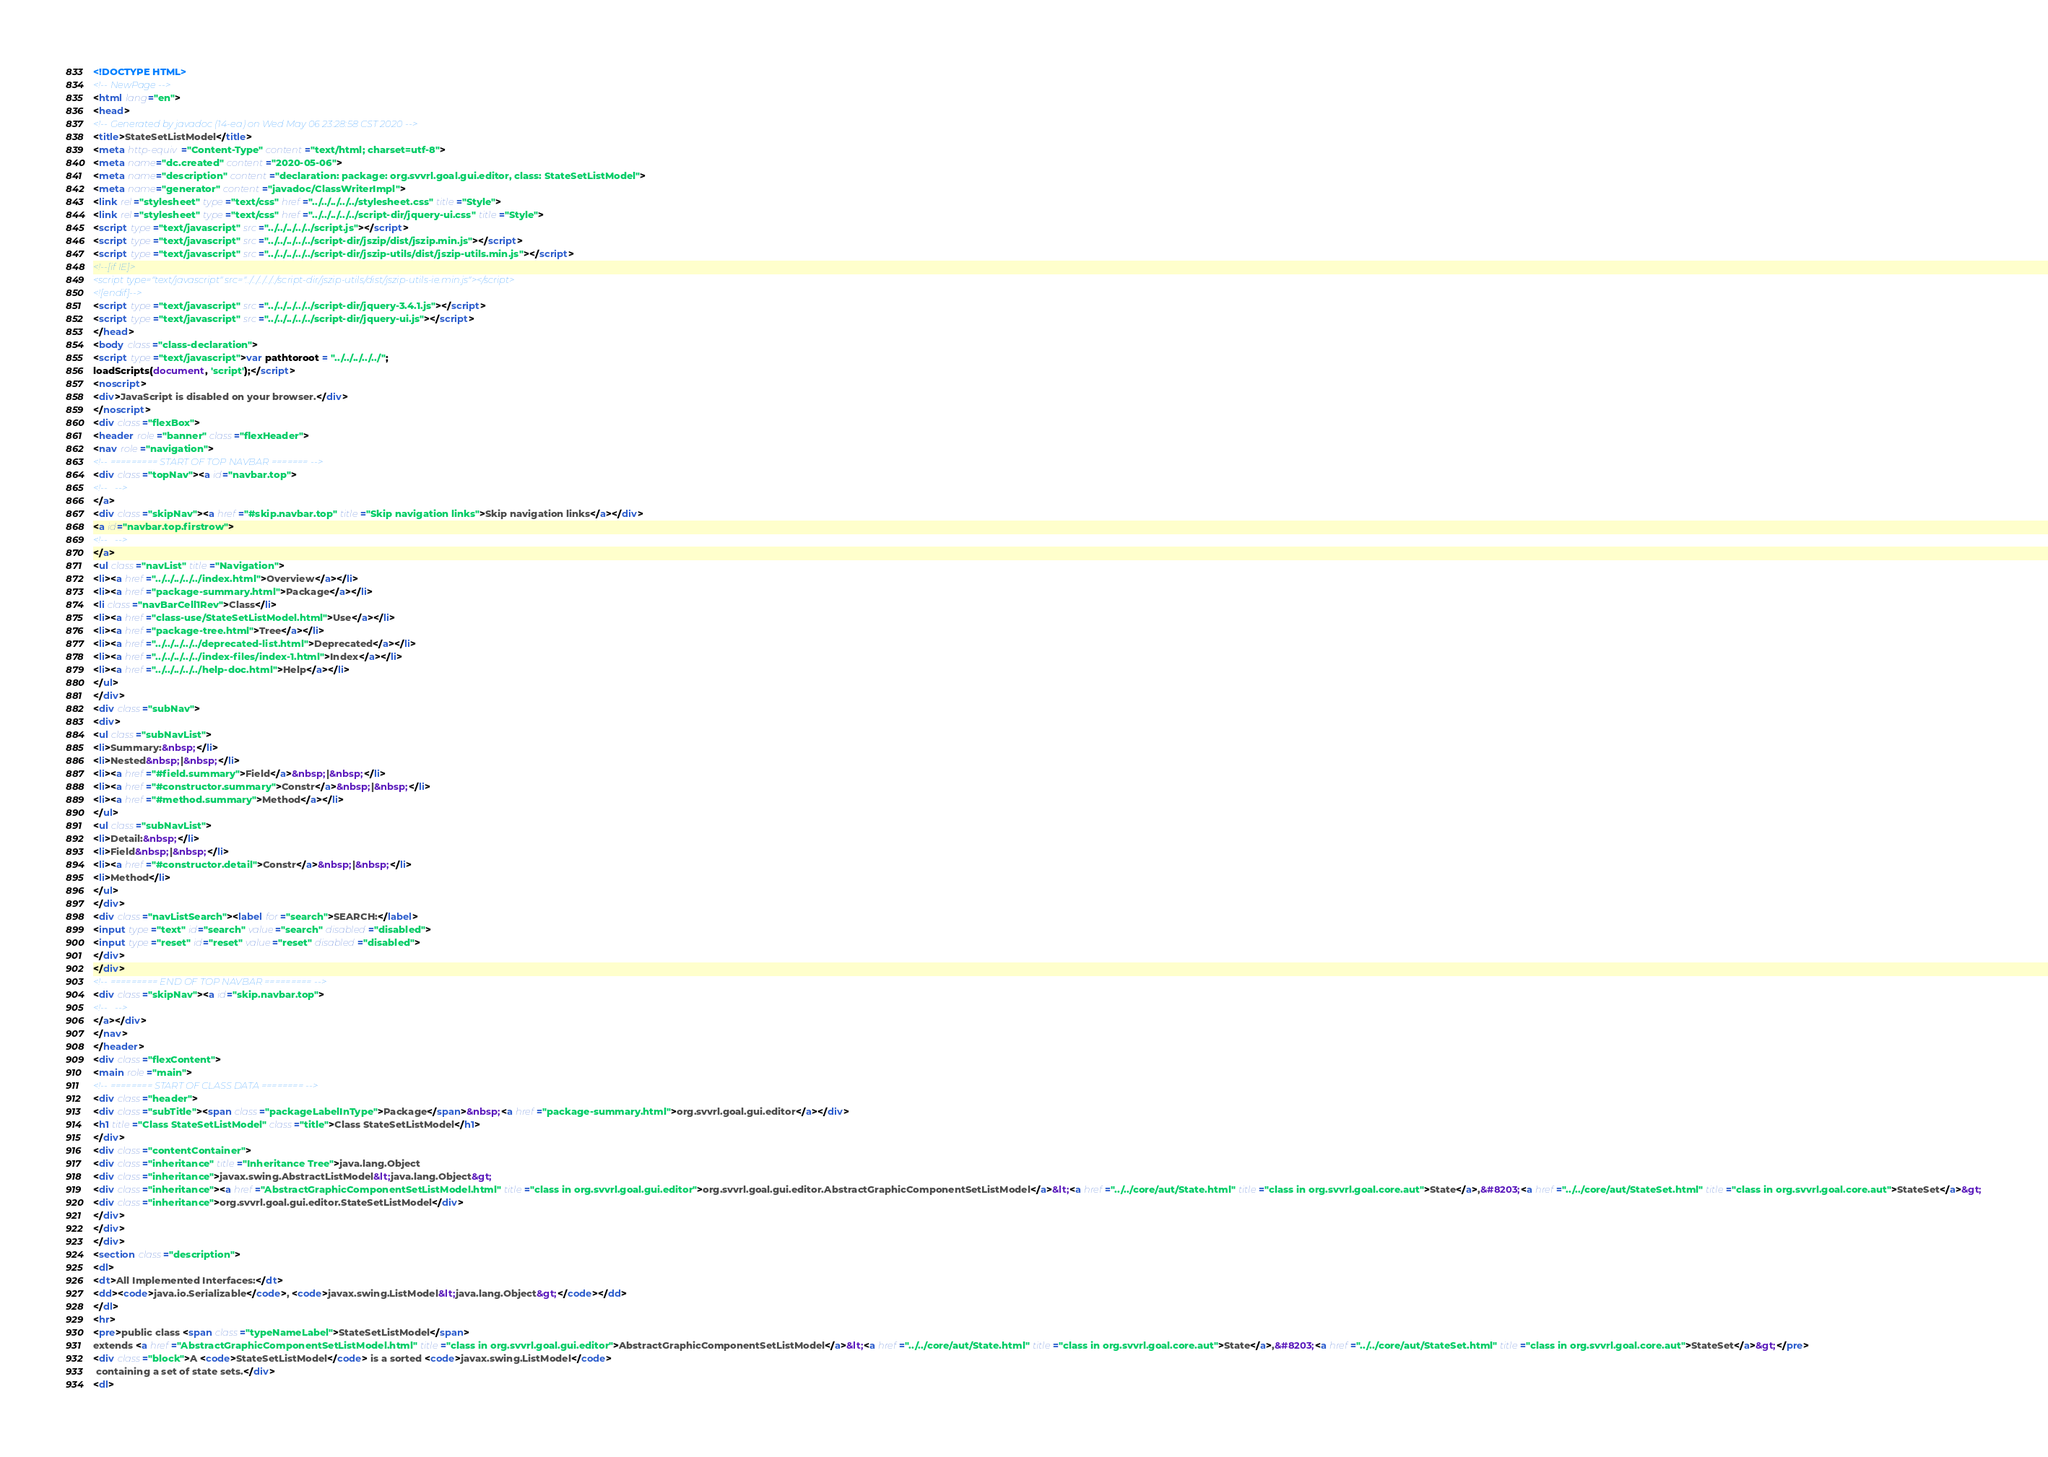Convert code to text. <code><loc_0><loc_0><loc_500><loc_500><_HTML_><!DOCTYPE HTML>
<!-- NewPage -->
<html lang="en">
<head>
<!-- Generated by javadoc (14-ea) on Wed May 06 23:28:58 CST 2020 -->
<title>StateSetListModel</title>
<meta http-equiv="Content-Type" content="text/html; charset=utf-8">
<meta name="dc.created" content="2020-05-06">
<meta name="description" content="declaration: package: org.svvrl.goal.gui.editor, class: StateSetListModel">
<meta name="generator" content="javadoc/ClassWriterImpl">
<link rel="stylesheet" type="text/css" href="../../../../../stylesheet.css" title="Style">
<link rel="stylesheet" type="text/css" href="../../../../../script-dir/jquery-ui.css" title="Style">
<script type="text/javascript" src="../../../../../script.js"></script>
<script type="text/javascript" src="../../../../../script-dir/jszip/dist/jszip.min.js"></script>
<script type="text/javascript" src="../../../../../script-dir/jszip-utils/dist/jszip-utils.min.js"></script>
<!--[if IE]>
<script type="text/javascript" src="../../../../../script-dir/jszip-utils/dist/jszip-utils-ie.min.js"></script>
<![endif]-->
<script type="text/javascript" src="../../../../../script-dir/jquery-3.4.1.js"></script>
<script type="text/javascript" src="../../../../../script-dir/jquery-ui.js"></script>
</head>
<body class="class-declaration">
<script type="text/javascript">var pathtoroot = "../../../../../";
loadScripts(document, 'script');</script>
<noscript>
<div>JavaScript is disabled on your browser.</div>
</noscript>
<div class="flexBox">
<header role="banner" class="flexHeader">
<nav role="navigation">
<!-- ========= START OF TOP NAVBAR ======= -->
<div class="topNav"><a id="navbar.top">
<!--   -->
</a>
<div class="skipNav"><a href="#skip.navbar.top" title="Skip navigation links">Skip navigation links</a></div>
<a id="navbar.top.firstrow">
<!--   -->
</a>
<ul class="navList" title="Navigation">
<li><a href="../../../../../index.html">Overview</a></li>
<li><a href="package-summary.html">Package</a></li>
<li class="navBarCell1Rev">Class</li>
<li><a href="class-use/StateSetListModel.html">Use</a></li>
<li><a href="package-tree.html">Tree</a></li>
<li><a href="../../../../../deprecated-list.html">Deprecated</a></li>
<li><a href="../../../../../index-files/index-1.html">Index</a></li>
<li><a href="../../../../../help-doc.html">Help</a></li>
</ul>
</div>
<div class="subNav">
<div>
<ul class="subNavList">
<li>Summary:&nbsp;</li>
<li>Nested&nbsp;|&nbsp;</li>
<li><a href="#field.summary">Field</a>&nbsp;|&nbsp;</li>
<li><a href="#constructor.summary">Constr</a>&nbsp;|&nbsp;</li>
<li><a href="#method.summary">Method</a></li>
</ul>
<ul class="subNavList">
<li>Detail:&nbsp;</li>
<li>Field&nbsp;|&nbsp;</li>
<li><a href="#constructor.detail">Constr</a>&nbsp;|&nbsp;</li>
<li>Method</li>
</ul>
</div>
<div class="navListSearch"><label for="search">SEARCH:</label>
<input type="text" id="search" value="search" disabled="disabled">
<input type="reset" id="reset" value="reset" disabled="disabled">
</div>
</div>
<!-- ========= END OF TOP NAVBAR ========= -->
<div class="skipNav"><a id="skip.navbar.top">
<!--   -->
</a></div>
</nav>
</header>
<div class="flexContent">
<main role="main">
<!-- ======== START OF CLASS DATA ======== -->
<div class="header">
<div class="subTitle"><span class="packageLabelInType">Package</span>&nbsp;<a href="package-summary.html">org.svvrl.goal.gui.editor</a></div>
<h1 title="Class StateSetListModel" class="title">Class StateSetListModel</h1>
</div>
<div class="contentContainer">
<div class="inheritance" title="Inheritance Tree">java.lang.Object
<div class="inheritance">javax.swing.AbstractListModel&lt;java.lang.Object&gt;
<div class="inheritance"><a href="AbstractGraphicComponentSetListModel.html" title="class in org.svvrl.goal.gui.editor">org.svvrl.goal.gui.editor.AbstractGraphicComponentSetListModel</a>&lt;<a href="../../core/aut/State.html" title="class in org.svvrl.goal.core.aut">State</a>,&#8203;<a href="../../core/aut/StateSet.html" title="class in org.svvrl.goal.core.aut">StateSet</a>&gt;
<div class="inheritance">org.svvrl.goal.gui.editor.StateSetListModel</div>
</div>
</div>
</div>
<section class="description">
<dl>
<dt>All Implemented Interfaces:</dt>
<dd><code>java.io.Serializable</code>, <code>javax.swing.ListModel&lt;java.lang.Object&gt;</code></dd>
</dl>
<hr>
<pre>public class <span class="typeNameLabel">StateSetListModel</span>
extends <a href="AbstractGraphicComponentSetListModel.html" title="class in org.svvrl.goal.gui.editor">AbstractGraphicComponentSetListModel</a>&lt;<a href="../../core/aut/State.html" title="class in org.svvrl.goal.core.aut">State</a>,&#8203;<a href="../../core/aut/StateSet.html" title="class in org.svvrl.goal.core.aut">StateSet</a>&gt;</pre>
<div class="block">A <code>StateSetListModel</code> is a sorted <code>javax.swing.ListModel</code>
 containing a set of state sets.</div>
<dl></code> 